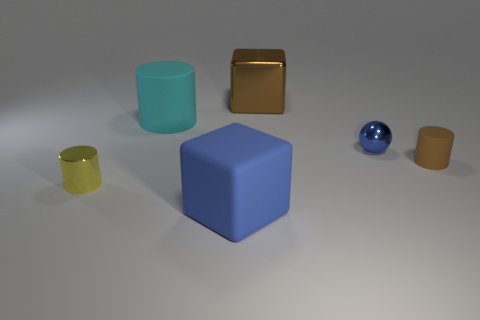What number of large objects are red metal spheres or brown cylinders?
Offer a terse response. 0. There is a large cyan object; what number of metal spheres are to the left of it?
Make the answer very short. 0. Is the number of things that are in front of the tiny blue ball greater than the number of tiny metal things?
Your response must be concise. Yes. What shape is the blue object that is made of the same material as the small yellow thing?
Offer a very short reply. Sphere. There is a cylinder that is on the left side of the cylinder that is behind the small blue ball; what is its color?
Offer a terse response. Yellow. Does the tiny yellow shiny object have the same shape as the small rubber thing?
Ensure brevity in your answer.  Yes. There is a large cyan object that is the same shape as the small brown thing; what is it made of?
Offer a very short reply. Rubber. There is a rubber object that is behind the matte object right of the large blue block; are there any objects behind it?
Give a very brief answer. Yes. Does the blue rubber object have the same shape as the big thing that is to the right of the big blue matte block?
Give a very brief answer. Yes. Is there anything else that has the same color as the big matte cube?
Provide a succinct answer. Yes. 